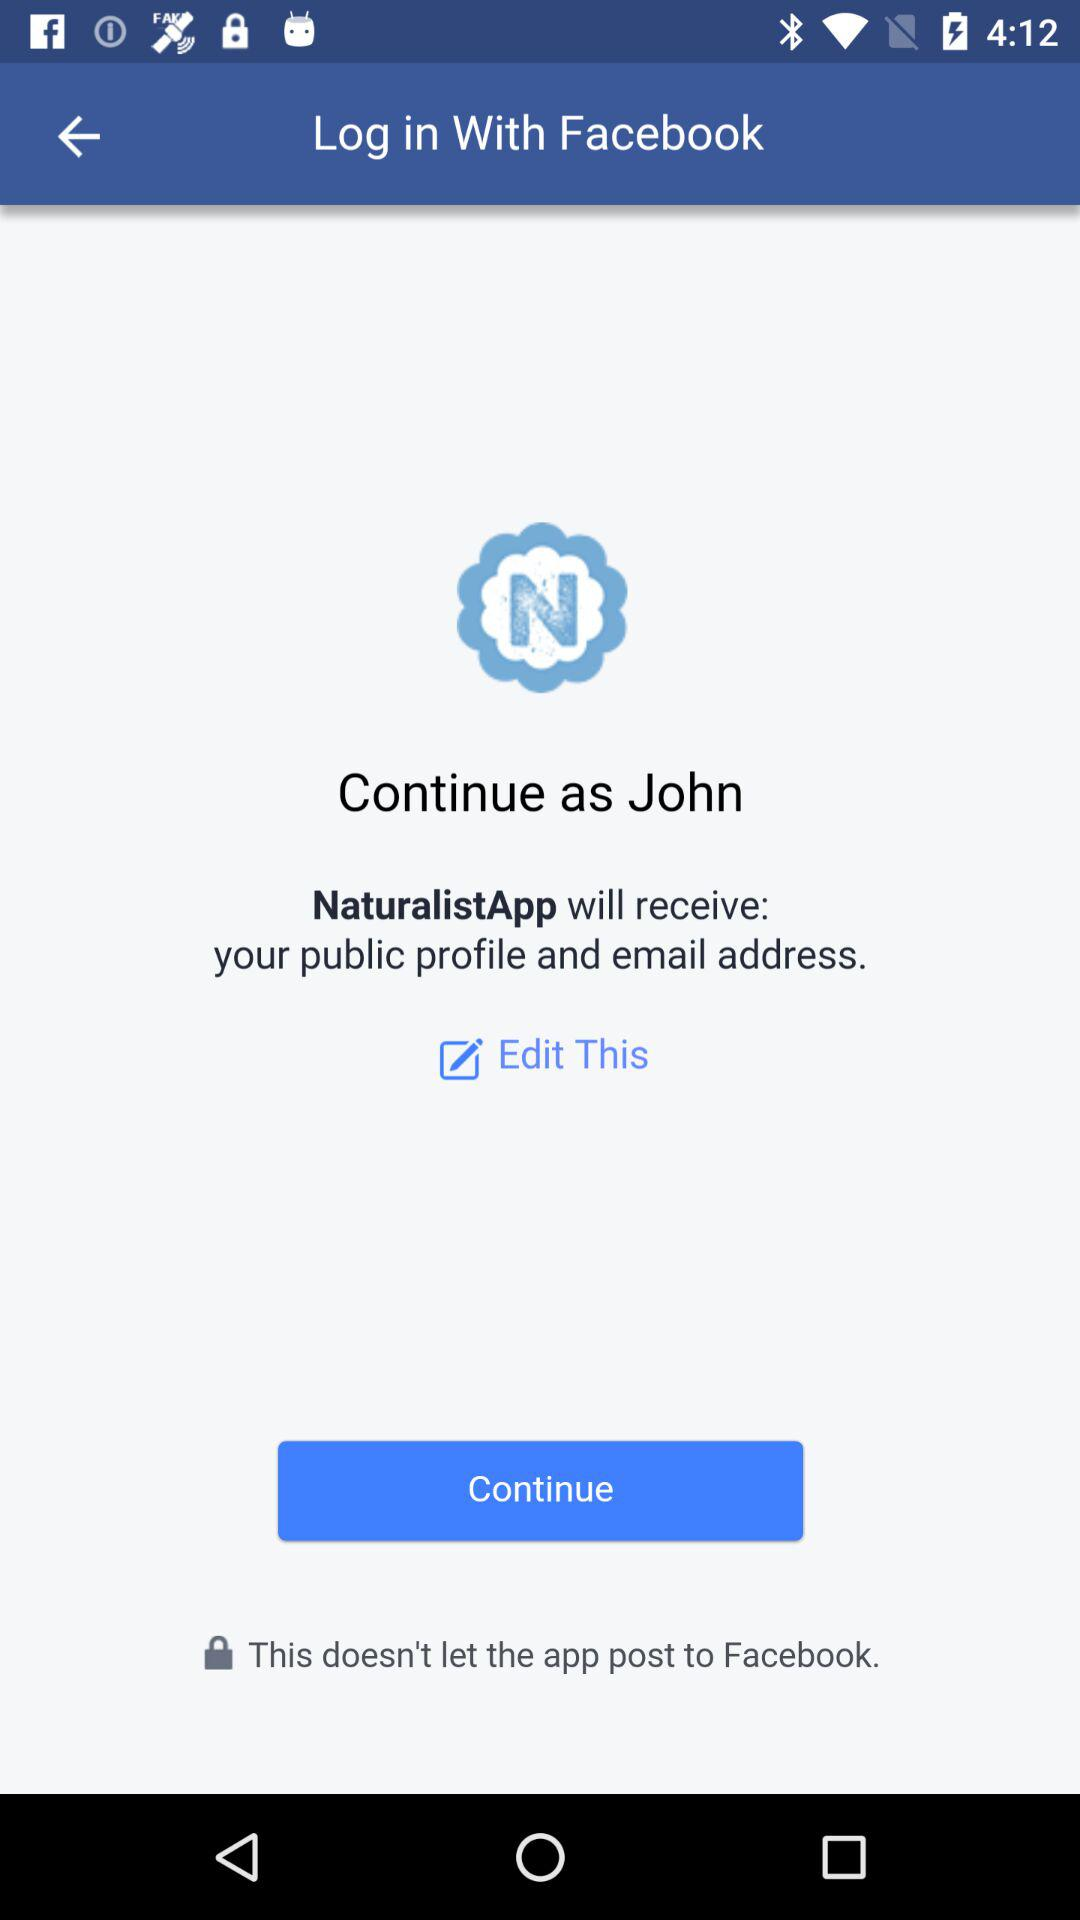Which application can logging in be done with? Logging in can be done with "Facebook". 